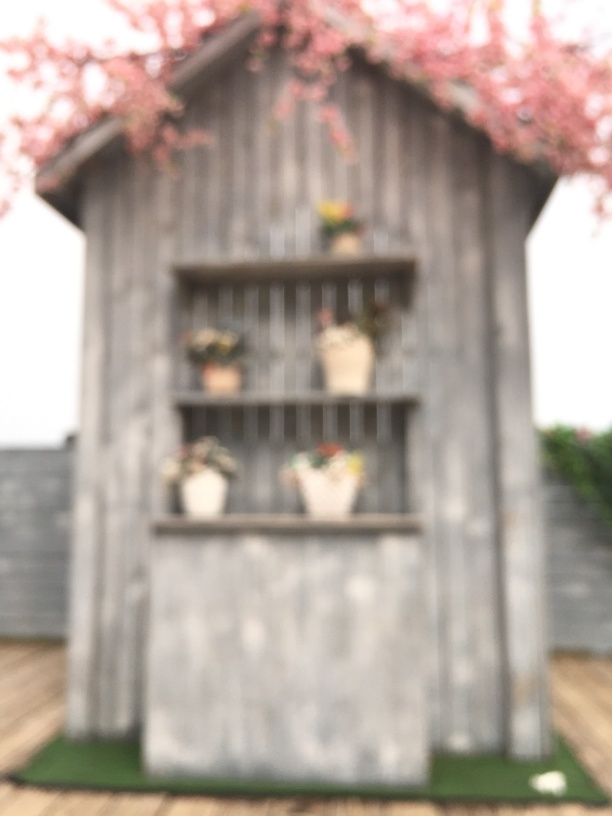Can you describe the atmosphere or mood the image portrays? The image exudes a serene and contemplative mood. The soft focus and blurred elements give a gentle and calming effect, and the presence of flowering branches and plants imparts a sense of growth and renewal. The overall composition suggests a tranquil retreat from the modern world. 